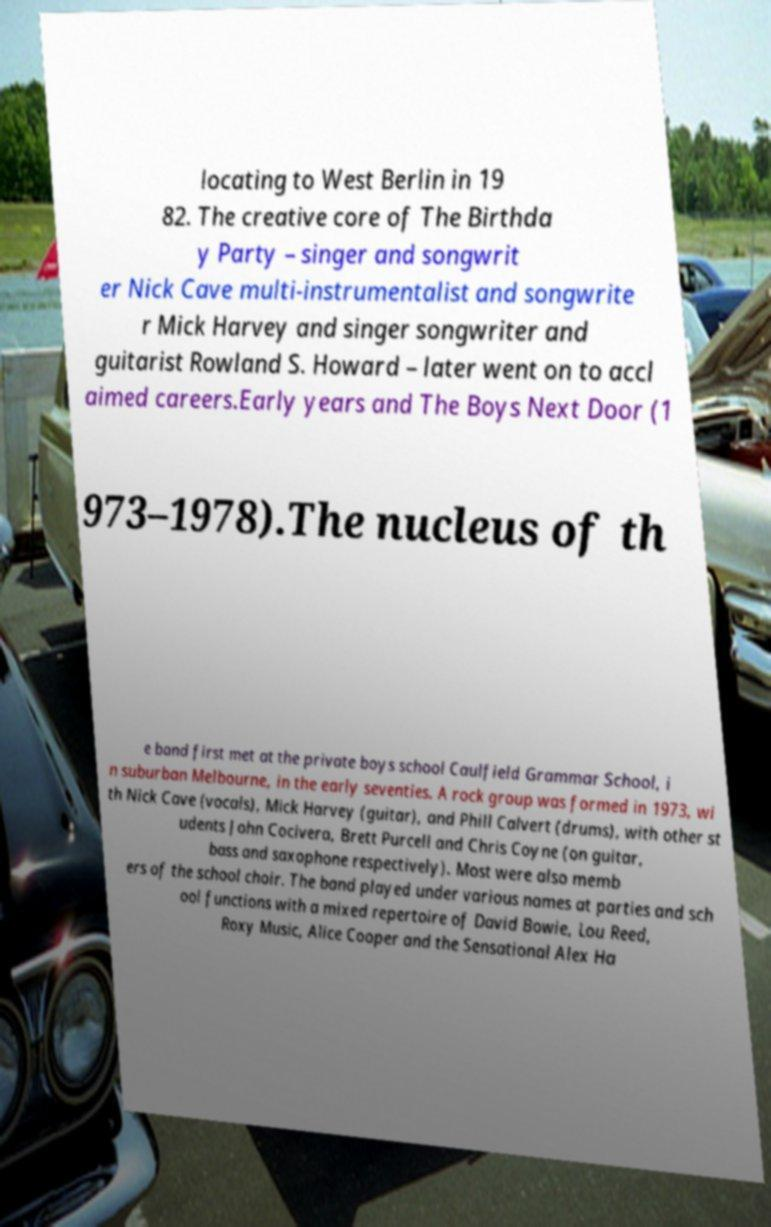Please identify and transcribe the text found in this image. locating to West Berlin in 19 82. The creative core of The Birthda y Party – singer and songwrit er Nick Cave multi-instrumentalist and songwrite r Mick Harvey and singer songwriter and guitarist Rowland S. Howard – later went on to accl aimed careers.Early years and The Boys Next Door (1 973–1978).The nucleus of th e band first met at the private boys school Caulfield Grammar School, i n suburban Melbourne, in the early seventies. A rock group was formed in 1973, wi th Nick Cave (vocals), Mick Harvey (guitar), and Phill Calvert (drums), with other st udents John Cocivera, Brett Purcell and Chris Coyne (on guitar, bass and saxophone respectively). Most were also memb ers of the school choir. The band played under various names at parties and sch ool functions with a mixed repertoire of David Bowie, Lou Reed, Roxy Music, Alice Cooper and the Sensational Alex Ha 